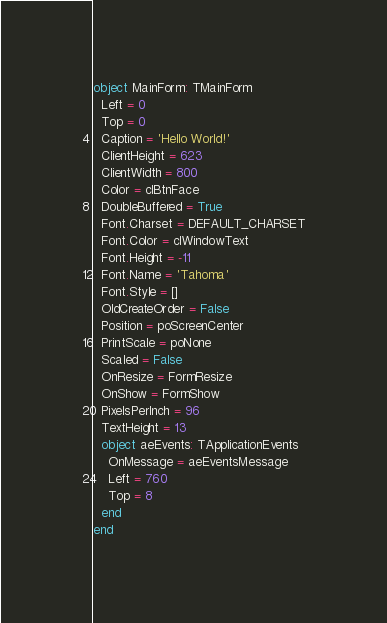<code> <loc_0><loc_0><loc_500><loc_500><_Pascal_>object MainForm: TMainForm
  Left = 0
  Top = 0
  Caption = 'Hello World!'
  ClientHeight = 623
  ClientWidth = 800
  Color = clBtnFace
  DoubleBuffered = True
  Font.Charset = DEFAULT_CHARSET
  Font.Color = clWindowText
  Font.Height = -11
  Font.Name = 'Tahoma'
  Font.Style = []
  OldCreateOrder = False
  Position = poScreenCenter
  PrintScale = poNone
  Scaled = False
  OnResize = FormResize
  OnShow = FormShow
  PixelsPerInch = 96
  TextHeight = 13
  object aeEvents: TApplicationEvents
    OnMessage = aeEventsMessage
    Left = 760
    Top = 8
  end
end
</code> 